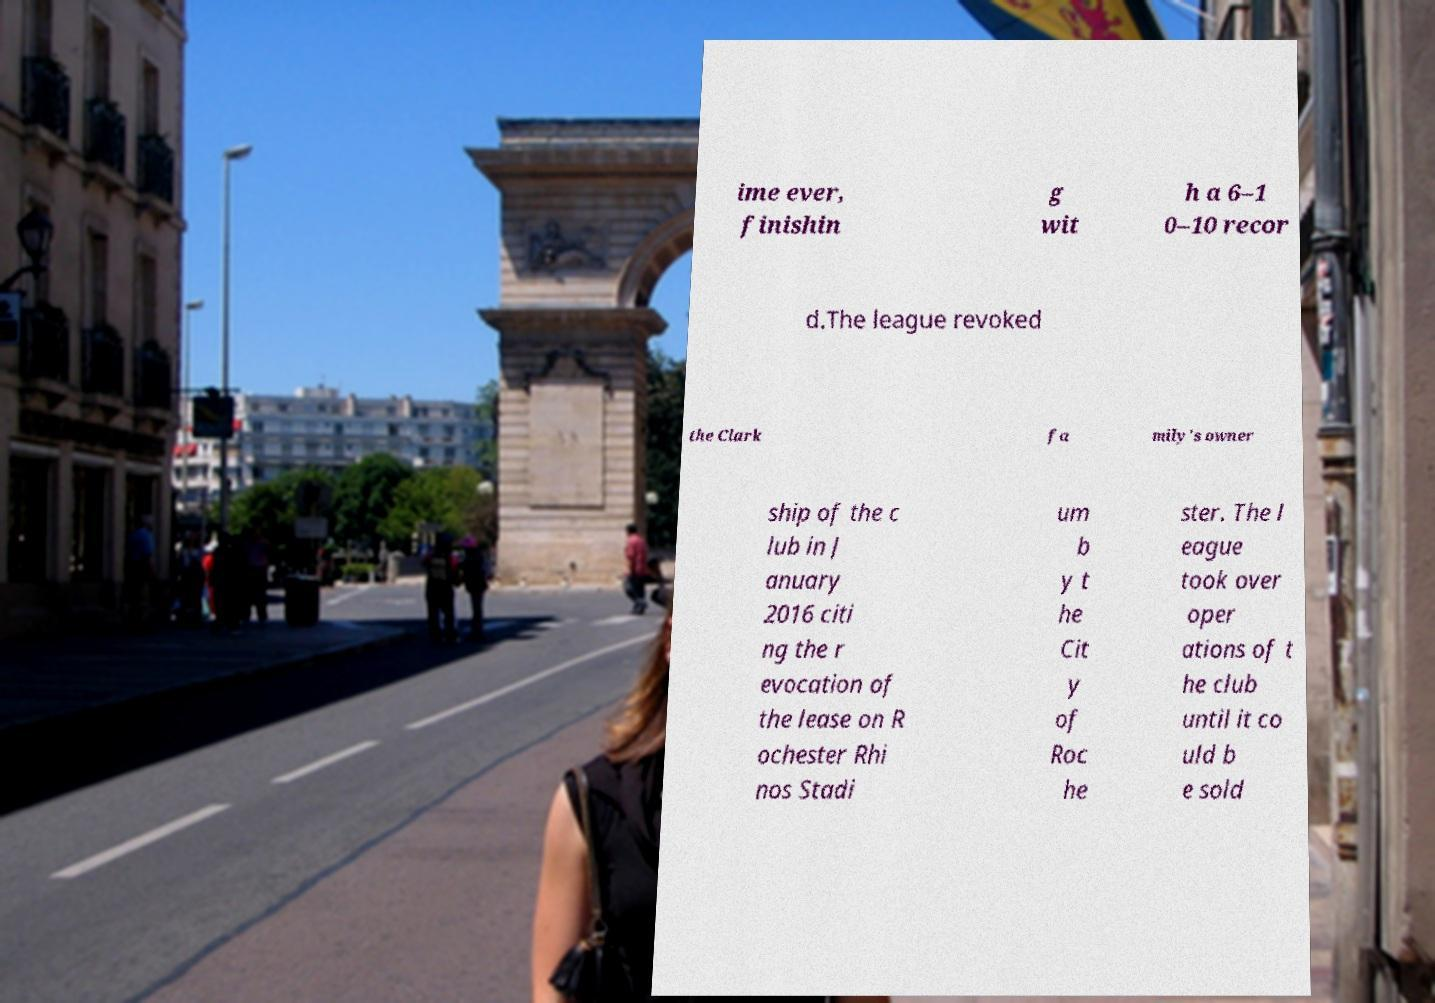There's text embedded in this image that I need extracted. Can you transcribe it verbatim? ime ever, finishin g wit h a 6–1 0–10 recor d.The league revoked the Clark fa mily's owner ship of the c lub in J anuary 2016 citi ng the r evocation of the lease on R ochester Rhi nos Stadi um b y t he Cit y of Roc he ster. The l eague took over oper ations of t he club until it co uld b e sold 